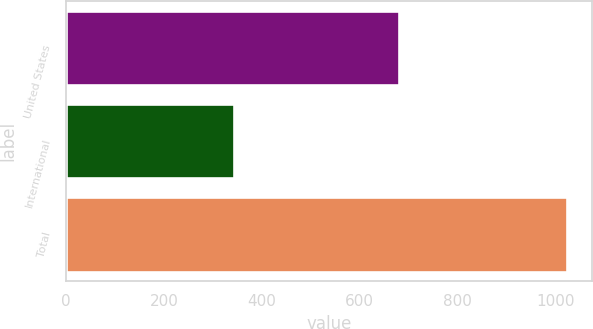Convert chart to OTSL. <chart><loc_0><loc_0><loc_500><loc_500><bar_chart><fcel>United States<fcel>International<fcel>Total<nl><fcel>680.8<fcel>342.5<fcel>1023.3<nl></chart> 